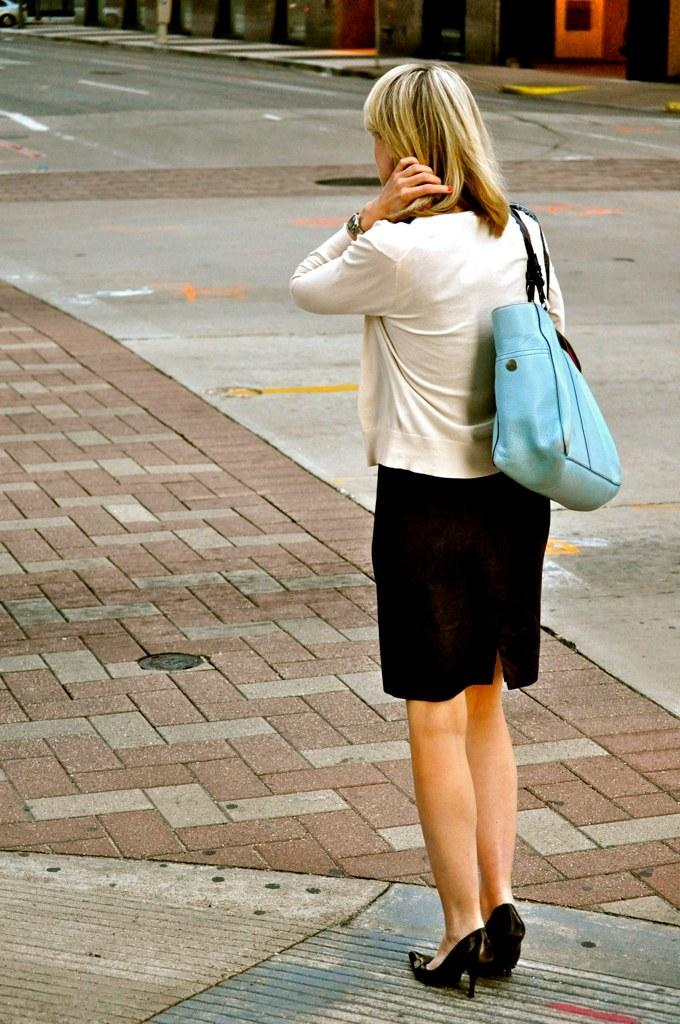Where was the picture taken? The picture was taken outside. Can you describe the person on the right side of the image? The person is wearing a sling bag and is standing on the ground. What is visible in the background of the image? There is a vehicle and other objects visible in the background of the image. What color is the crayon being used by the person in the image? There is no crayon present in the image. Can you tell me how many chess pieces are visible in the image? There are no chess pieces visible in the image. 